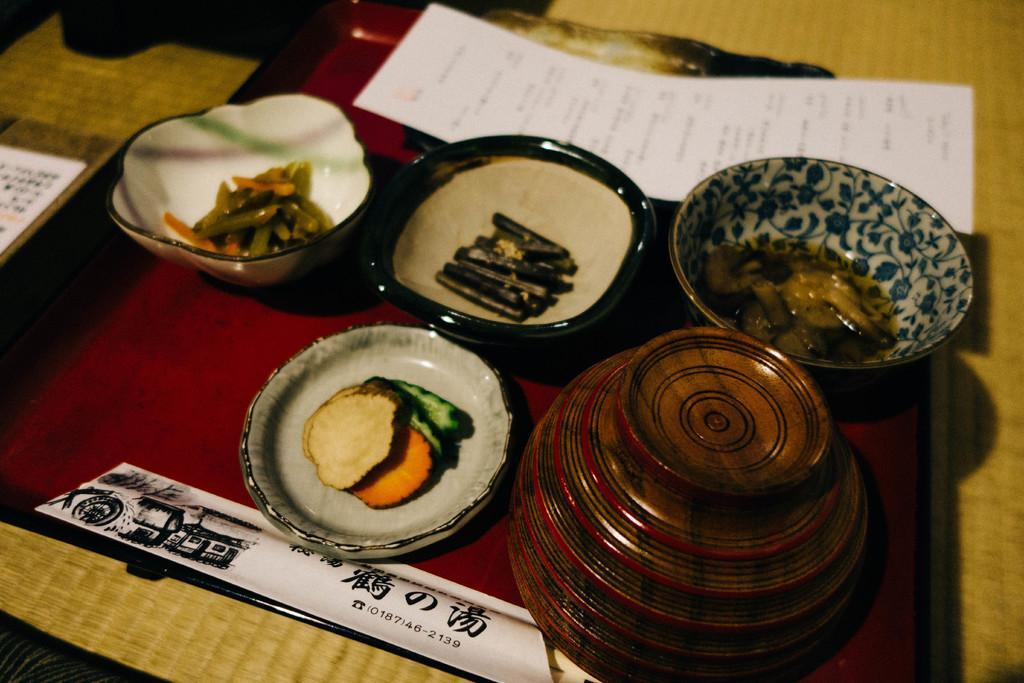Describe this image in one or two sentences. There are some bowls with some food items kept on a surface as we can see in the middle of this image. There is a white color paper at the top of this image. 